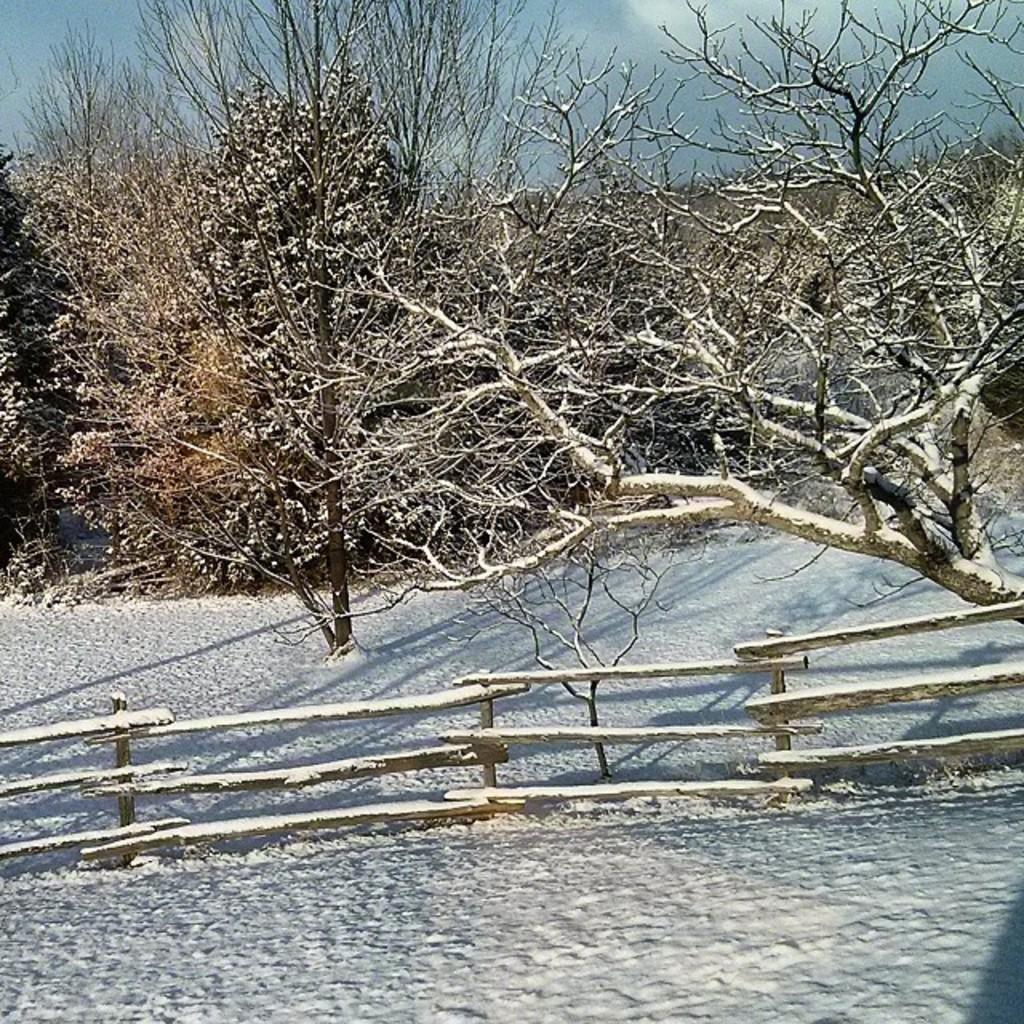What is the primary feature of the landscape in the image? There is snow in the image. What type of structure can be seen in the image? There is a wooden fence in the image. What type of vegetation is present in the image? There are trees in the image. What type of tax is being discussed in the image? There is no discussion of tax in the image; it features snow, a wooden fence, and trees. 